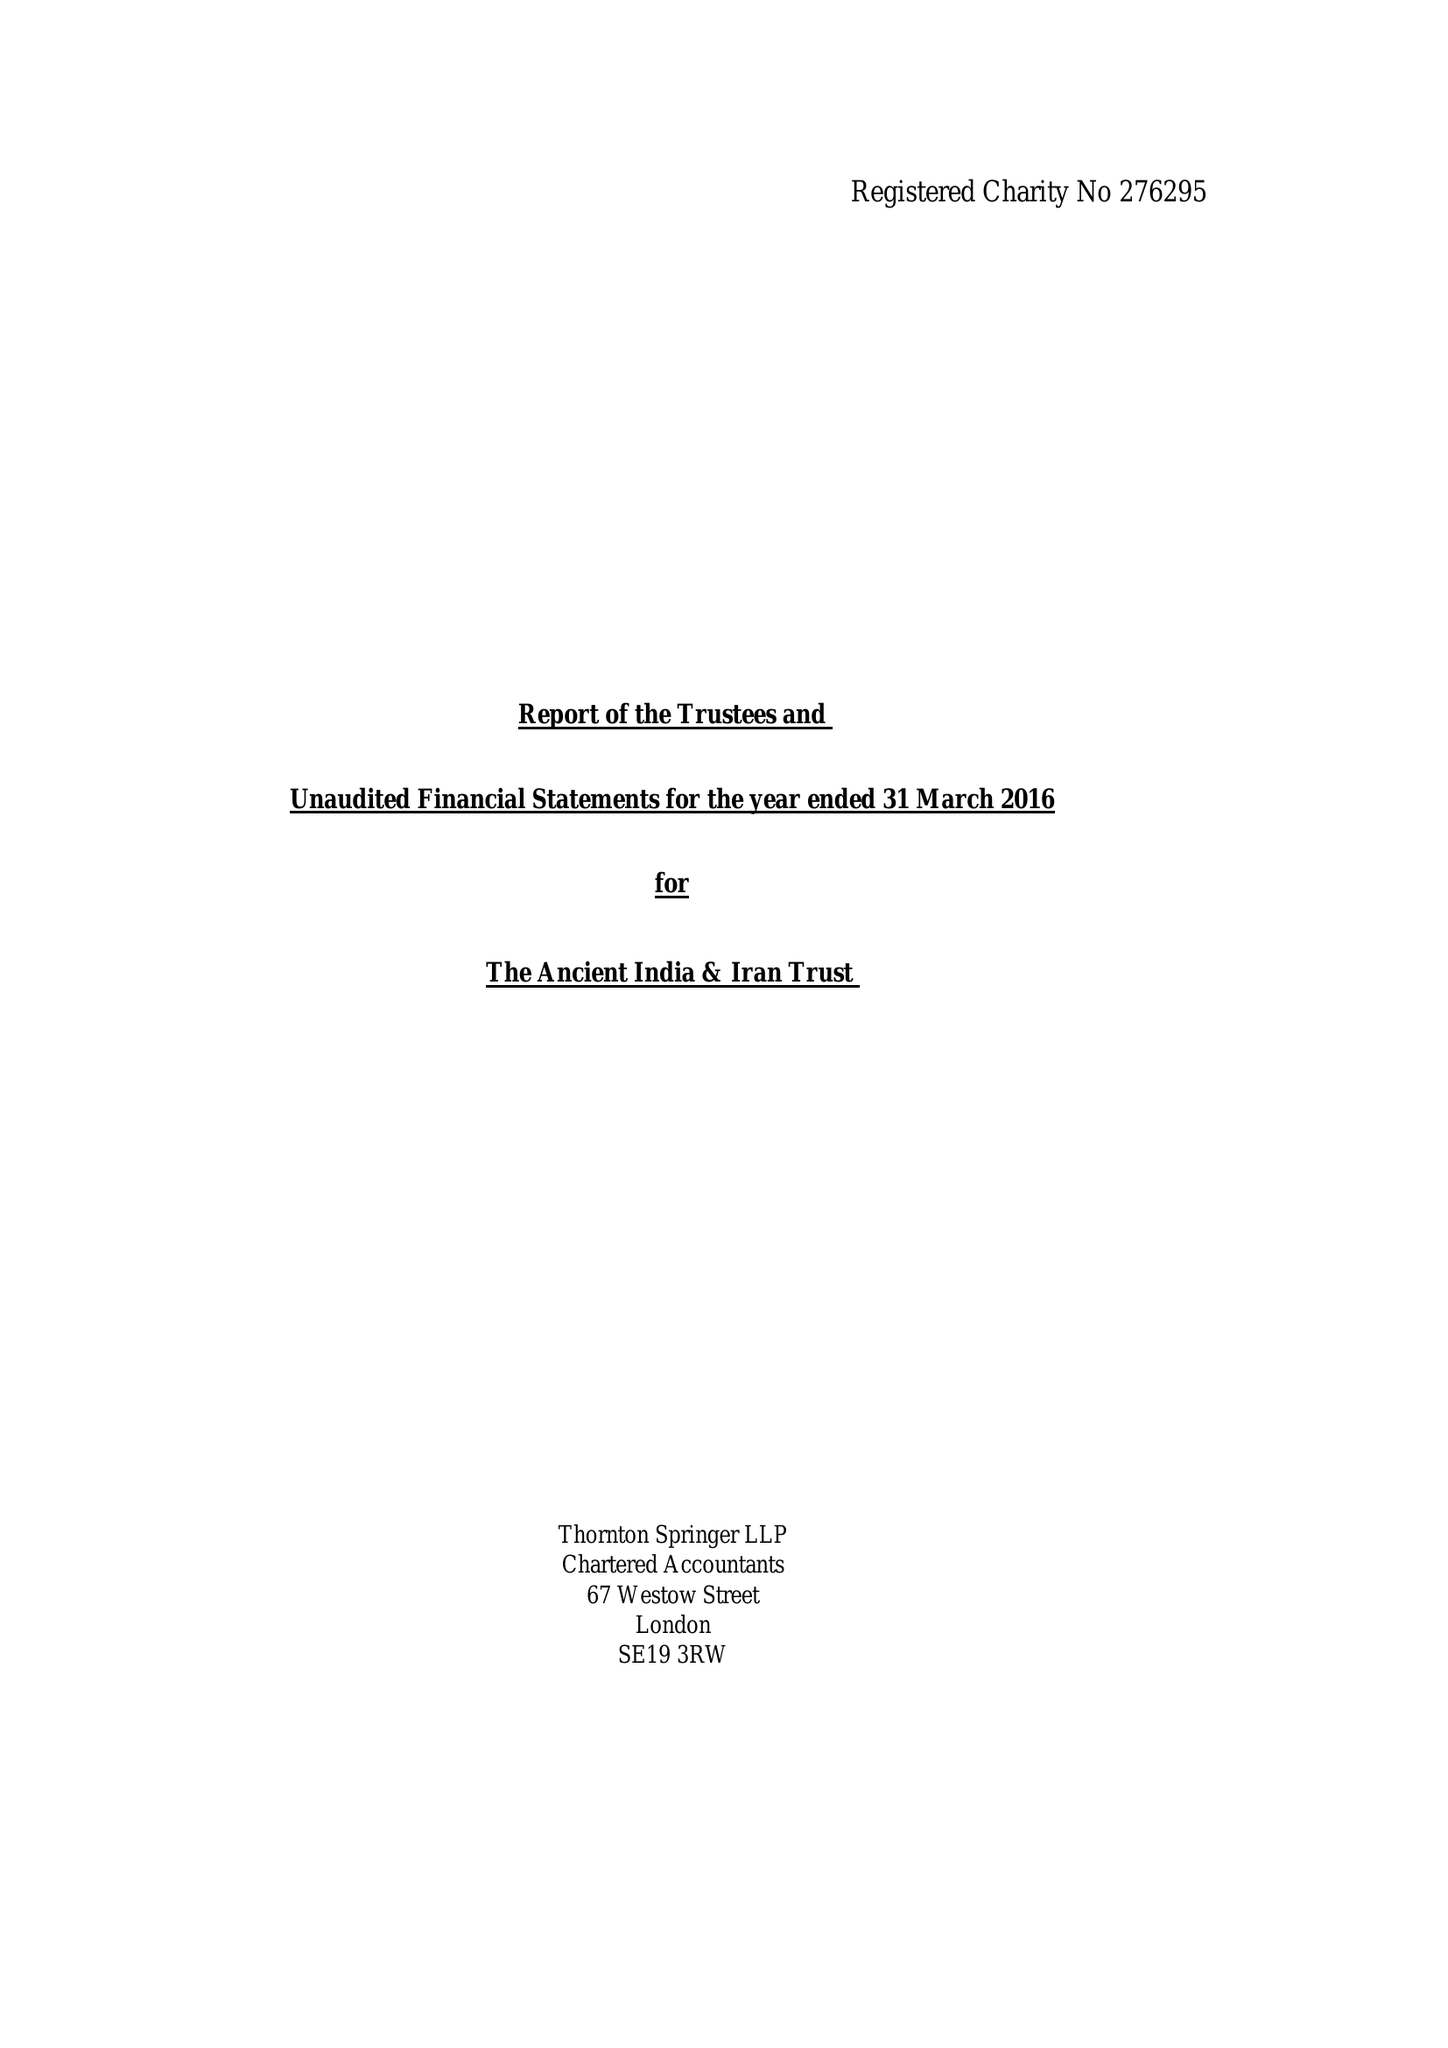What is the value for the income_annually_in_british_pounds?
Answer the question using a single word or phrase. 87180.00 